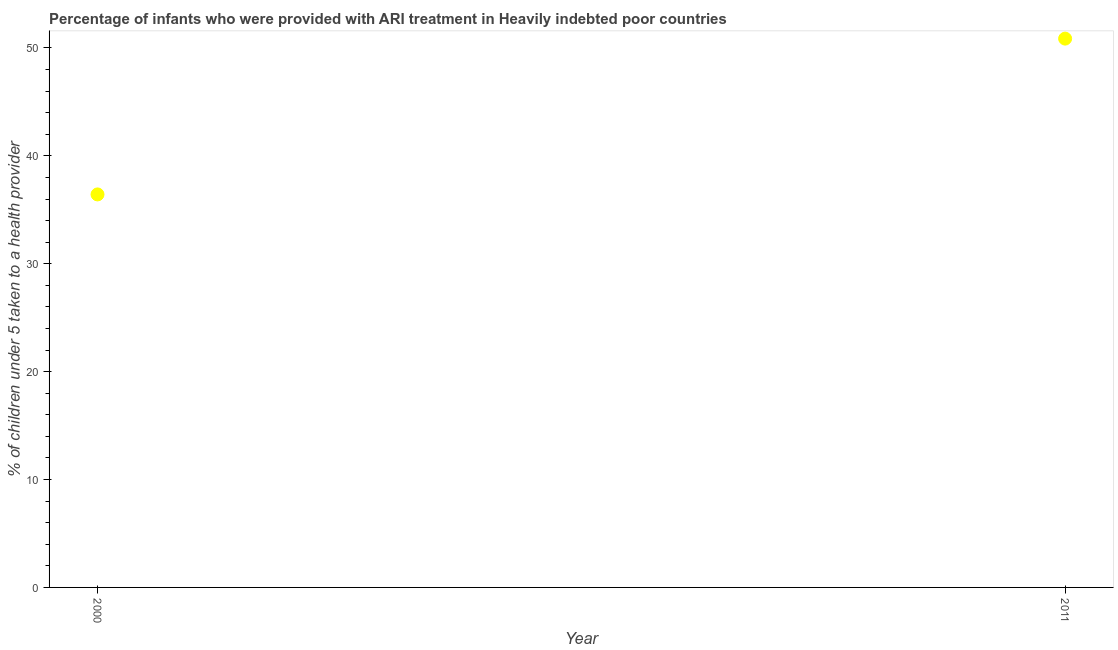What is the percentage of children who were provided with ari treatment in 2000?
Offer a terse response. 36.43. Across all years, what is the maximum percentage of children who were provided with ari treatment?
Give a very brief answer. 50.87. Across all years, what is the minimum percentage of children who were provided with ari treatment?
Ensure brevity in your answer.  36.43. In which year was the percentage of children who were provided with ari treatment minimum?
Give a very brief answer. 2000. What is the sum of the percentage of children who were provided with ari treatment?
Your answer should be very brief. 87.29. What is the difference between the percentage of children who were provided with ari treatment in 2000 and 2011?
Make the answer very short. -14.44. What is the average percentage of children who were provided with ari treatment per year?
Offer a very short reply. 43.65. What is the median percentage of children who were provided with ari treatment?
Provide a succinct answer. 43.65. In how many years, is the percentage of children who were provided with ari treatment greater than 28 %?
Offer a terse response. 2. Do a majority of the years between 2011 and 2000 (inclusive) have percentage of children who were provided with ari treatment greater than 46 %?
Your answer should be compact. No. What is the ratio of the percentage of children who were provided with ari treatment in 2000 to that in 2011?
Keep it short and to the point. 0.72. In how many years, is the percentage of children who were provided with ari treatment greater than the average percentage of children who were provided with ari treatment taken over all years?
Your response must be concise. 1. Does the percentage of children who were provided with ari treatment monotonically increase over the years?
Keep it short and to the point. Yes. How many dotlines are there?
Provide a succinct answer. 1. Are the values on the major ticks of Y-axis written in scientific E-notation?
Provide a short and direct response. No. What is the title of the graph?
Ensure brevity in your answer.  Percentage of infants who were provided with ARI treatment in Heavily indebted poor countries. What is the label or title of the X-axis?
Your answer should be compact. Year. What is the label or title of the Y-axis?
Offer a terse response. % of children under 5 taken to a health provider. What is the % of children under 5 taken to a health provider in 2000?
Offer a terse response. 36.43. What is the % of children under 5 taken to a health provider in 2011?
Make the answer very short. 50.87. What is the difference between the % of children under 5 taken to a health provider in 2000 and 2011?
Offer a very short reply. -14.44. What is the ratio of the % of children under 5 taken to a health provider in 2000 to that in 2011?
Ensure brevity in your answer.  0.72. 